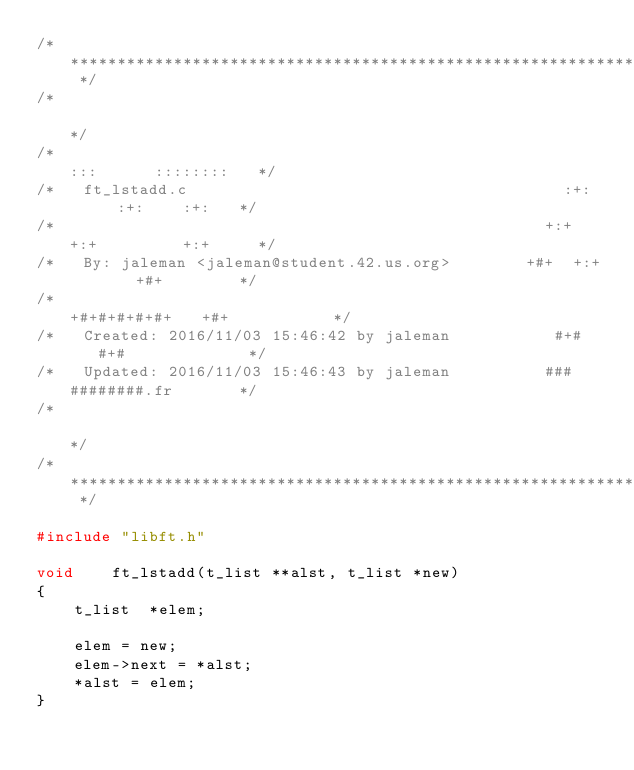<code> <loc_0><loc_0><loc_500><loc_500><_C_>/* ************************************************************************** */
/*                                                                            */
/*                                                        :::      ::::::::   */
/*   ft_lstadd.c                                        :+:      :+:    :+:   */
/*                                                    +:+ +:+         +:+     */
/*   By: jaleman <jaleman@student.42.us.org>        +#+  +:+       +#+        */
/*                                                +#+#+#+#+#+   +#+           */
/*   Created: 2016/11/03 15:46:42 by jaleman           #+#    #+#             */
/*   Updated: 2016/11/03 15:46:43 by jaleman          ###   ########.fr       */
/*                                                                            */
/* ************************************************************************** */

#include "libft.h"

void	ft_lstadd(t_list **alst, t_list *new)
{
	t_list	*elem;

	elem = new;
	elem->next = *alst;
	*alst = elem;
}
</code> 